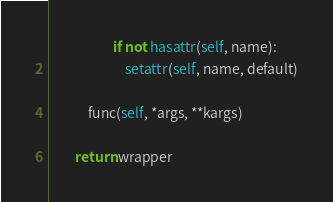Convert code to text. <code><loc_0><loc_0><loc_500><loc_500><_Python_>                    if not hasattr(self, name):
                        setattr(self, name, default)

            func(self, *args, **kargs)

        return wrapper</code> 